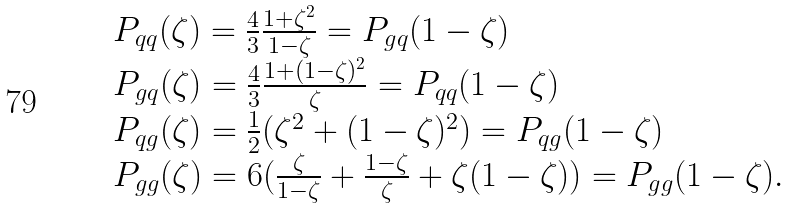Convert formula to latex. <formula><loc_0><loc_0><loc_500><loc_500>\begin{array} { l } P _ { q q } ( \zeta ) = \frac { 4 } { 3 } \frac { 1 + \zeta ^ { 2 } } { 1 - \zeta } = P _ { g q } ( 1 - \zeta ) \\ P _ { g q } ( \zeta ) = \frac { 4 } { 3 } \frac { 1 + ( 1 - \zeta ) ^ { 2 } } { \zeta } = P _ { q q } ( 1 - \zeta ) \\ P _ { q g } ( \zeta ) = \frac { 1 } { 2 } ( \zeta ^ { 2 } + ( 1 - \zeta ) ^ { 2 } ) = P _ { q g } ( 1 - \zeta ) \\ P _ { g g } ( \zeta ) = 6 ( \frac { \zeta } { 1 - \zeta } + \frac { 1 - \zeta } { \zeta } + \zeta ( 1 - \zeta ) ) = P _ { g g } ( 1 - \zeta ) . \end{array}</formula> 